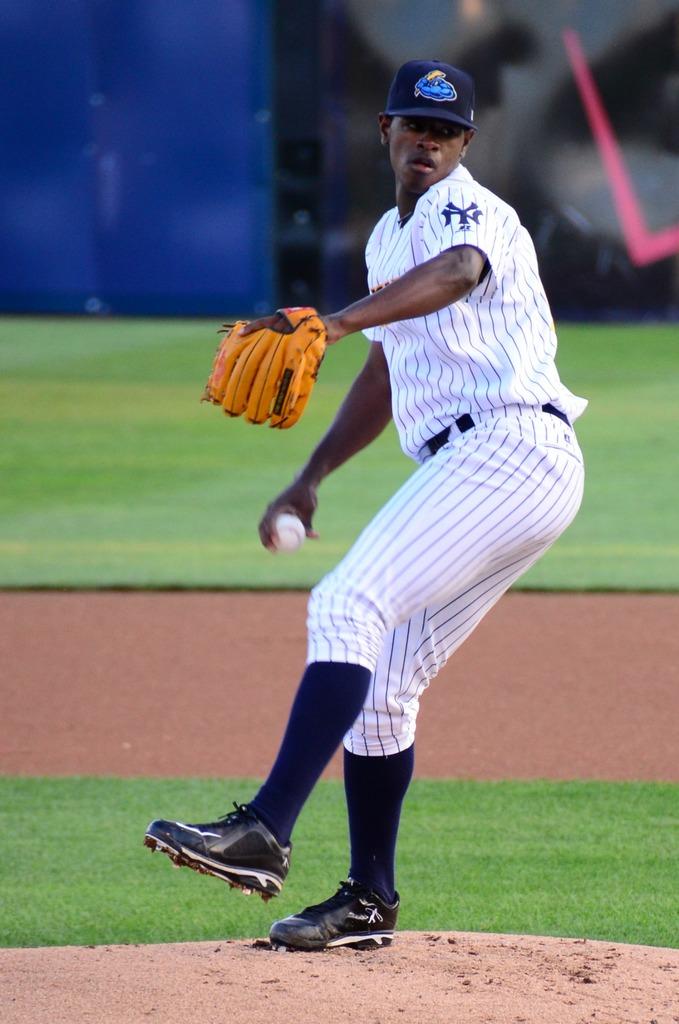What does the yankees logo look like?
Offer a very short reply. Unanswerable. 